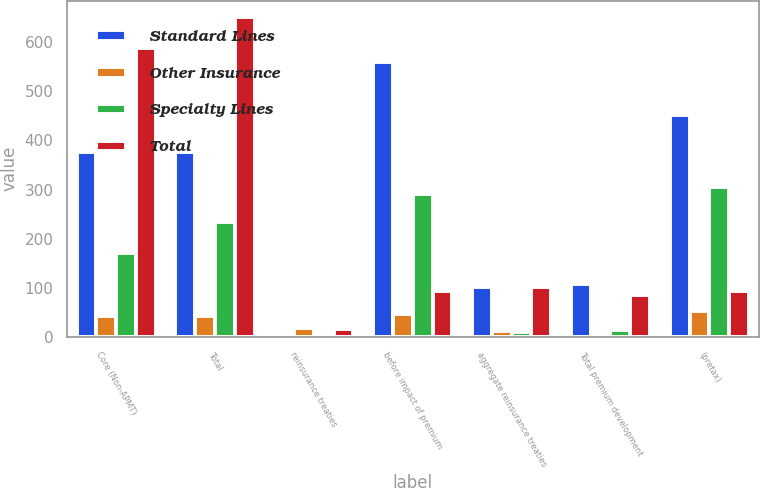<chart> <loc_0><loc_0><loc_500><loc_500><stacked_bar_chart><ecel><fcel>Core (Non-APMT)<fcel>Total<fcel>reinsurance treaties<fcel>before impact of premium<fcel>aggregate reinsurance treaties<fcel>Total premium development<fcel>(pretax)<nl><fcel>Standard Lines<fcel>376<fcel>376<fcel>6<fcel>559<fcel>101<fcel>107<fcel>452<nl><fcel>Other Insurance<fcel>42<fcel>42<fcel>19<fcel>47<fcel>12<fcel>7<fcel>54<nl><fcel>Specialty Lines<fcel>171<fcel>234<fcel>4<fcel>291<fcel>11<fcel>15<fcel>306<nl><fcel>Total<fcel>589<fcel>652<fcel>17<fcel>93<fcel>102<fcel>85<fcel>93<nl></chart> 